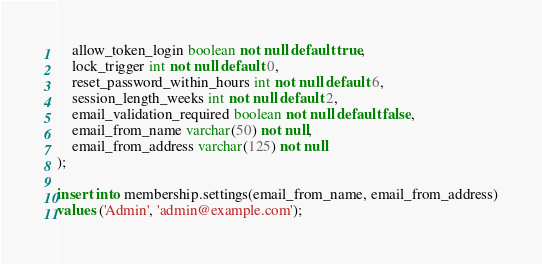Convert code to text. <code><loc_0><loc_0><loc_500><loc_500><_SQL_>    allow_token_login boolean not null default true,
    lock_trigger int not null default 0,
    reset_password_within_hours int not null default 6,
    session_length_weeks int not null default 2,
    email_validation_required boolean not null default false,
    email_from_name varchar(50) not null,
    email_from_address varchar(125) not null
);

insert into membership.settings(email_from_name, email_from_address)
values ('Admin', 'admin@example.com');</code> 